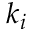<formula> <loc_0><loc_0><loc_500><loc_500>k _ { i }</formula> 